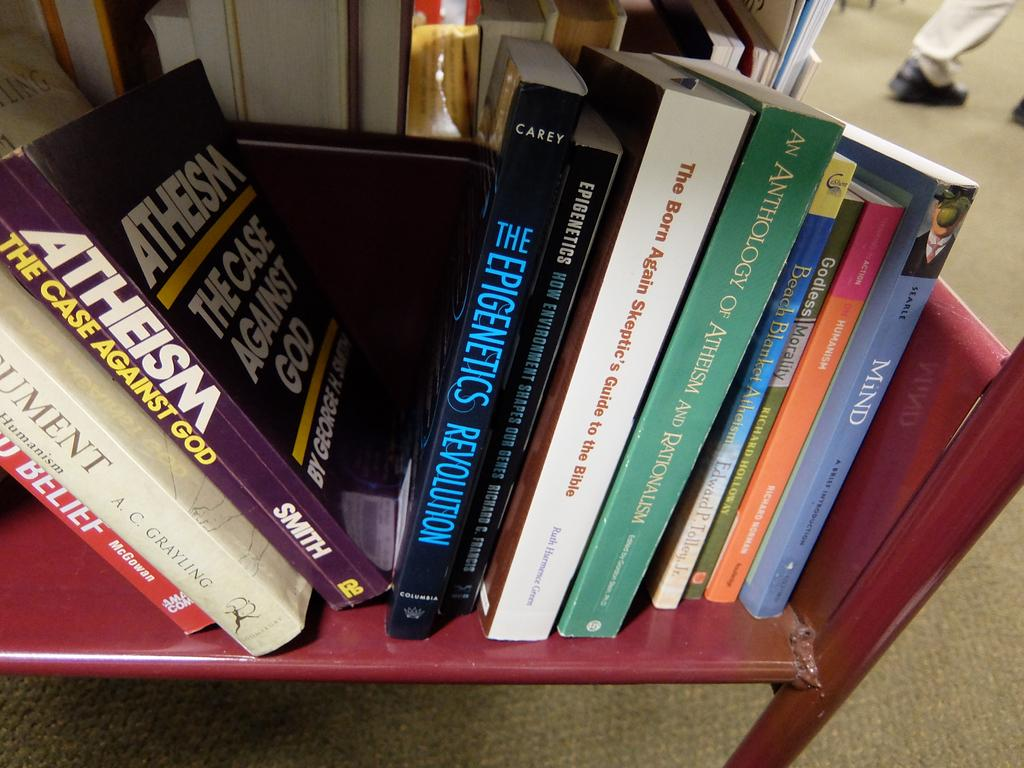What type of furniture is present in the image? There is a bookshelf in the image. Can you describe any other objects or features visible in the image? There are legs visible in the top right corner of the image. What type of record is being played on the bookshelf in the image? There is no record or record player present in the image; it only features a bookshelf and legs. 